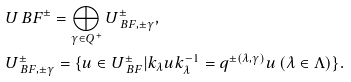Convert formula to latex. <formula><loc_0><loc_0><loc_500><loc_500>& U _ { \ } B F ^ { \pm } = \bigoplus _ { \gamma \in Q ^ { + } } U _ { \ B F , \pm \gamma } ^ { \pm } , \quad \\ & U _ { \ B F , \pm \gamma } ^ { \pm } = \{ u \in U _ { \ B F } ^ { \pm } | k _ { \lambda } u k _ { \lambda } ^ { - 1 } = q ^ { \pm ( \lambda , \gamma ) } u \, ( \lambda \in \Lambda ) \} .</formula> 